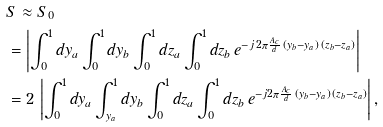Convert formula to latex. <formula><loc_0><loc_0><loc_500><loc_500>& S \approx S _ { 0 } \\ & = \left | \int _ { 0 } ^ { 1 } d y _ { a } \int _ { 0 } ^ { 1 } d y _ { b } \int _ { 0 } ^ { 1 } d z _ { a } \int _ { 0 } ^ { 1 } d z _ { b } \, e ^ { - j \, 2 \pi \frac { A _ { c } } { d } \, ( y _ { b } - y _ { a } ) \, ( z _ { b } - z _ { a } ) } \right | \\ & = 2 \, \left | \int _ { 0 } ^ { 1 } d y _ { a } \int _ { y _ { a } } ^ { 1 } d y _ { b } \int _ { 0 } ^ { 1 } d z _ { a } \int _ { 0 } ^ { 1 } d z _ { b } \, e ^ { - j 2 \pi \frac { A _ { c } } { d } \, ( y _ { b } - y _ { a } ) \, ( z _ { b } - z _ { a } ) } \right | ,</formula> 